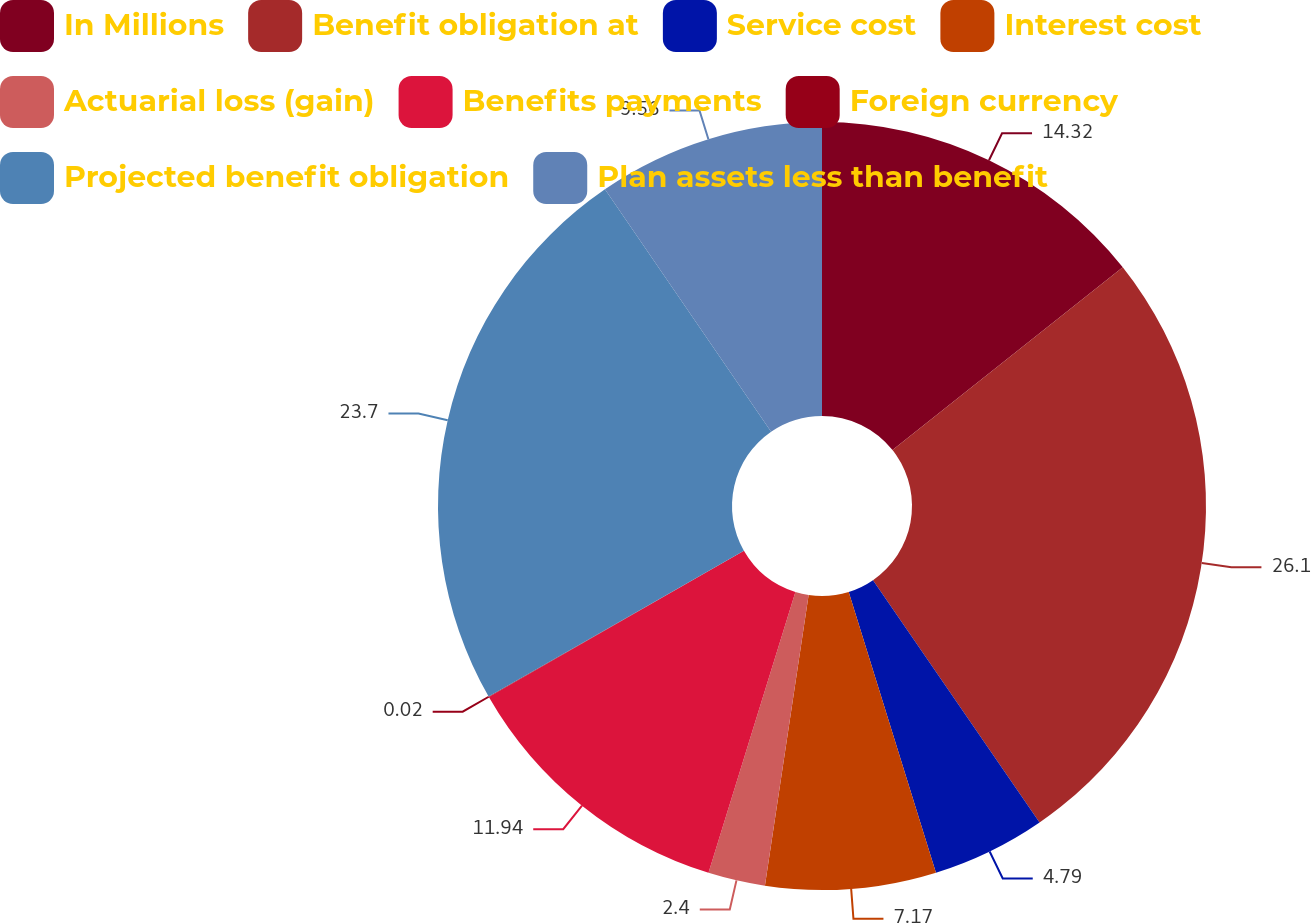<chart> <loc_0><loc_0><loc_500><loc_500><pie_chart><fcel>In Millions<fcel>Benefit obligation at<fcel>Service cost<fcel>Interest cost<fcel>Actuarial loss (gain)<fcel>Benefits payments<fcel>Foreign currency<fcel>Projected benefit obligation<fcel>Plan assets less than benefit<nl><fcel>14.32%<fcel>26.09%<fcel>4.79%<fcel>7.17%<fcel>2.4%<fcel>11.94%<fcel>0.02%<fcel>23.7%<fcel>9.56%<nl></chart> 